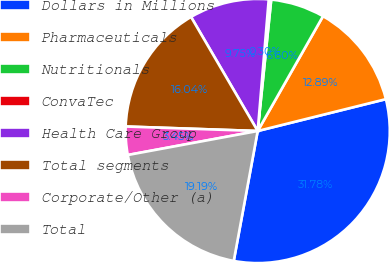<chart> <loc_0><loc_0><loc_500><loc_500><pie_chart><fcel>Dollars in Millions<fcel>Pharmaceuticals<fcel>Nutritionals<fcel>ConvaTec<fcel>Health Care Group<fcel>Total segments<fcel>Corporate/Other (a)<fcel>Total<nl><fcel>31.78%<fcel>12.89%<fcel>6.6%<fcel>0.3%<fcel>9.75%<fcel>16.04%<fcel>3.45%<fcel>19.19%<nl></chart> 